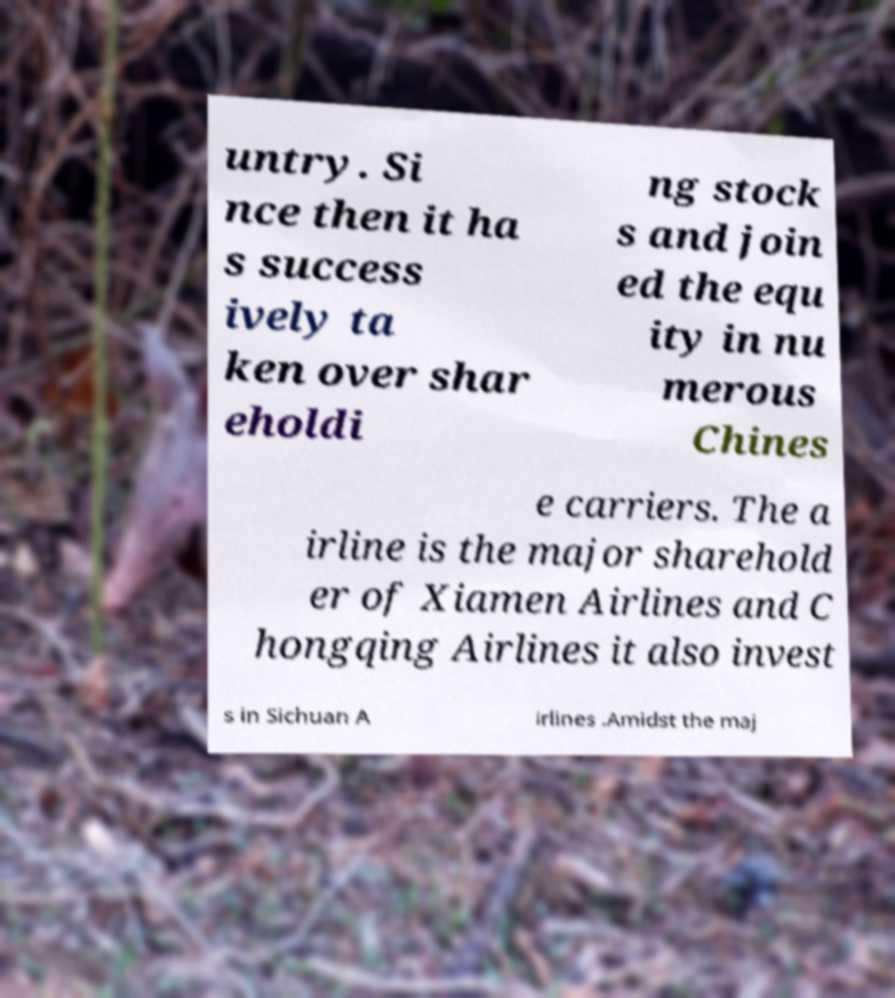Could you extract and type out the text from this image? untry. Si nce then it ha s success ively ta ken over shar eholdi ng stock s and join ed the equ ity in nu merous Chines e carriers. The a irline is the major sharehold er of Xiamen Airlines and C hongqing Airlines it also invest s in Sichuan A irlines .Amidst the maj 